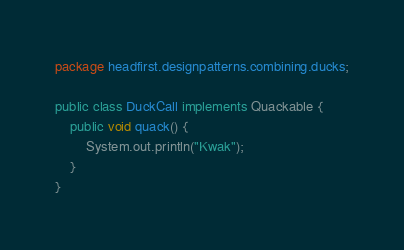Convert code to text. <code><loc_0><loc_0><loc_500><loc_500><_Java_>package headfirst.designpatterns.combining.ducks;

public class DuckCall implements Quackable {
	public void quack() {
		System.out.println("Kwak");
	}
}
</code> 